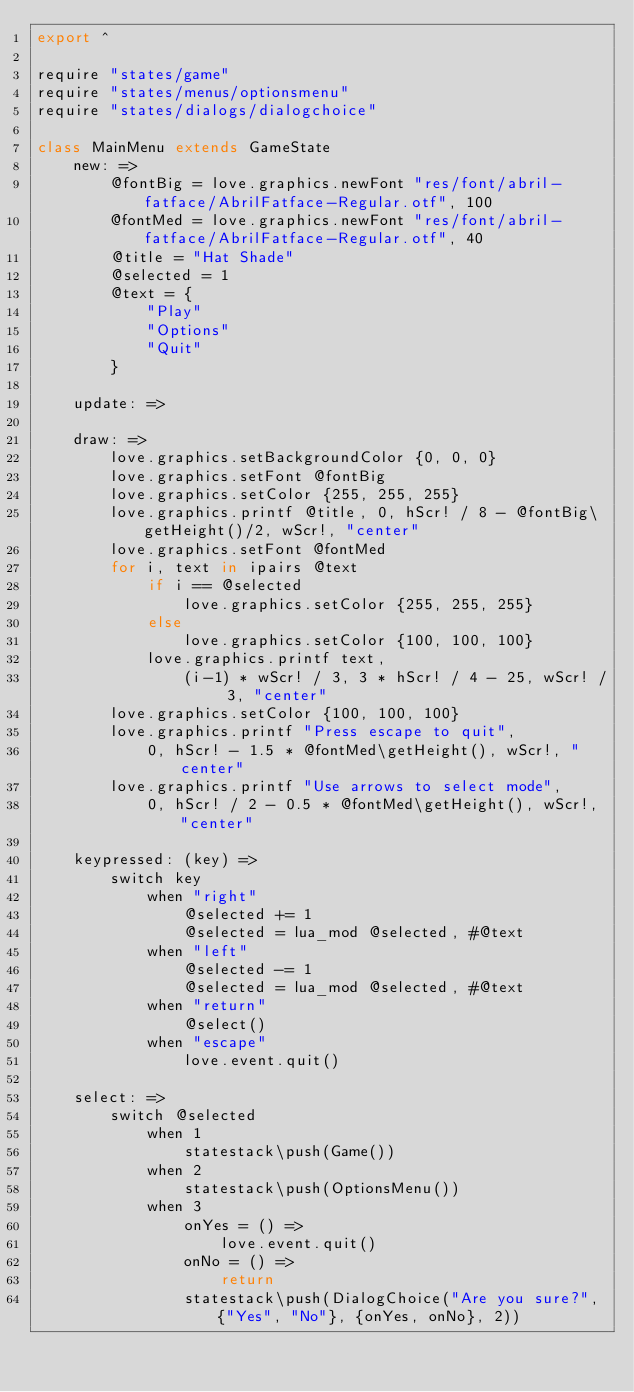<code> <loc_0><loc_0><loc_500><loc_500><_MoonScript_>export ^

require "states/game"
require "states/menus/optionsmenu"
require "states/dialogs/dialogchoice"

class MainMenu extends GameState
    new: =>
        @fontBig = love.graphics.newFont "res/font/abril-fatface/AbrilFatface-Regular.otf", 100
        @fontMed = love.graphics.newFont "res/font/abril-fatface/AbrilFatface-Regular.otf", 40
        @title = "Hat Shade"
        @selected = 1
        @text = {
            "Play"
            "Options"
            "Quit"
        }

    update: =>

    draw: =>
        love.graphics.setBackgroundColor {0, 0, 0}
        love.graphics.setFont @fontBig
        love.graphics.setColor {255, 255, 255}
        love.graphics.printf @title, 0, hScr! / 8 - @fontBig\getHeight()/2, wScr!, "center"
        love.graphics.setFont @fontMed
        for i, text in ipairs @text
            if i == @selected
                love.graphics.setColor {255, 255, 255}
            else
                love.graphics.setColor {100, 100, 100}
            love.graphics.printf text,
                (i-1) * wScr! / 3, 3 * hScr! / 4 - 25, wScr! / 3, "center"
        love.graphics.setColor {100, 100, 100}
        love.graphics.printf "Press escape to quit",
            0, hScr! - 1.5 * @fontMed\getHeight(), wScr!, "center"
        love.graphics.printf "Use arrows to select mode",
            0, hScr! / 2 - 0.5 * @fontMed\getHeight(), wScr!, "center"

    keypressed: (key) =>
        switch key
            when "right"
                @selected += 1
                @selected = lua_mod @selected, #@text
            when "left"
                @selected -= 1
                @selected = lua_mod @selected, #@text
            when "return"
                @select()
            when "escape"
                love.event.quit()

    select: =>
        switch @selected
            when 1
                statestack\push(Game())
            when 2
                statestack\push(OptionsMenu())
            when 3
                onYes = () =>
                    love.event.quit()
                onNo = () =>
                    return
                statestack\push(DialogChoice("Are you sure?", {"Yes", "No"}, {onYes, onNo}, 2))
</code> 